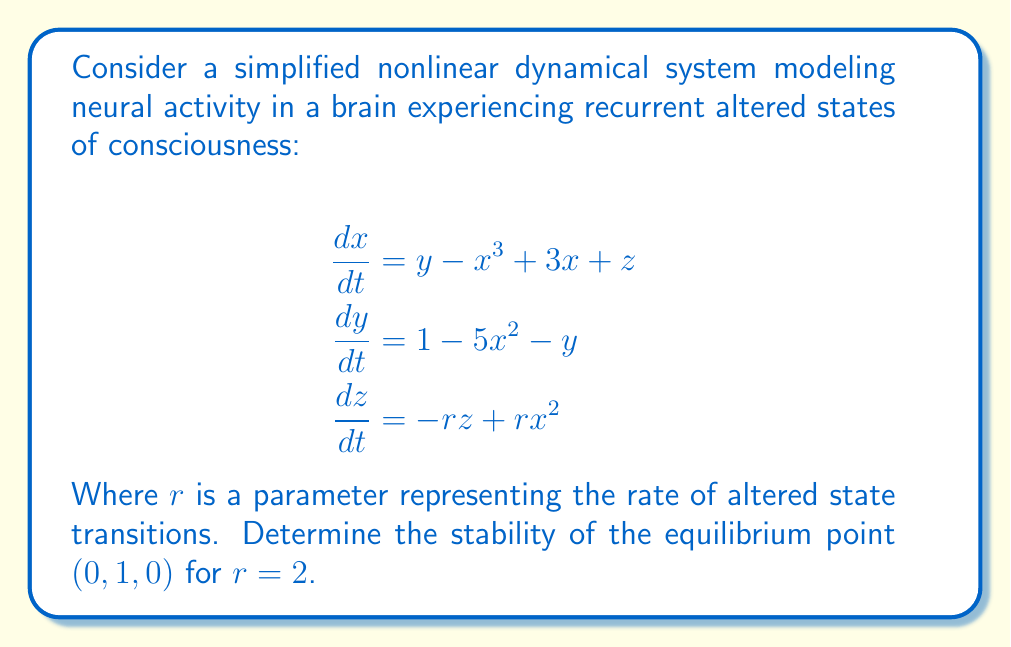Can you answer this question? 1) First, we need to calculate the Jacobian matrix of the system at the equilibrium point $(0, 1, 0)$:

   $$J = \begin{bmatrix}
   \frac{\partial f_1}{\partial x} & \frac{\partial f_1}{\partial y} & \frac{\partial f_1}{\partial z} \\
   \frac{\partial f_2}{\partial x} & \frac{\partial f_2}{\partial y} & \frac{\partial f_2}{\partial z} \\
   \frac{\partial f_3}{\partial x} & \frac{\partial f_3}{\partial y} & \frac{\partial f_3}{\partial z}
   \end{bmatrix}$$

2) Calculating the partial derivatives:

   $$J = \begin{bmatrix}
   -3x^2 + 3 & 1 & 1 \\
   -10x & -1 & 0 \\
   2rx & 0 & -r
   \end{bmatrix}$$

3) Evaluating at the equilibrium point $(0, 1, 0)$ with $r = 2$:

   $$J_{(0,1,0)} = \begin{bmatrix}
   3 & 1 & 1 \\
   0 & -1 & 0 \\
   0 & 0 & -2
   \end{bmatrix}$$

4) To determine stability, we need to find the eigenvalues of this matrix. The characteristic equation is:

   $$det(J_{(0,1,0)} - \lambda I) = 0$$

   $$(3-\lambda)(-1-\lambda)(-2-\lambda) - 0 = 0$$

5) Expanding:

   $$-\lambda^3 + \lambda^2 + 7\lambda + 6 = 0$$

6) The roots of this equation are the eigenvalues. Using the cubic formula or numerical methods, we find:

   $$\lambda_1 \approx 3.2143$$
   $$\lambda_2 \approx -1.8358$$
   $$\lambda_3 \approx -2.3785$$

7) Since one eigenvalue ($\lambda_1$) is positive, the equilibrium point is unstable.
Answer: Unstable 